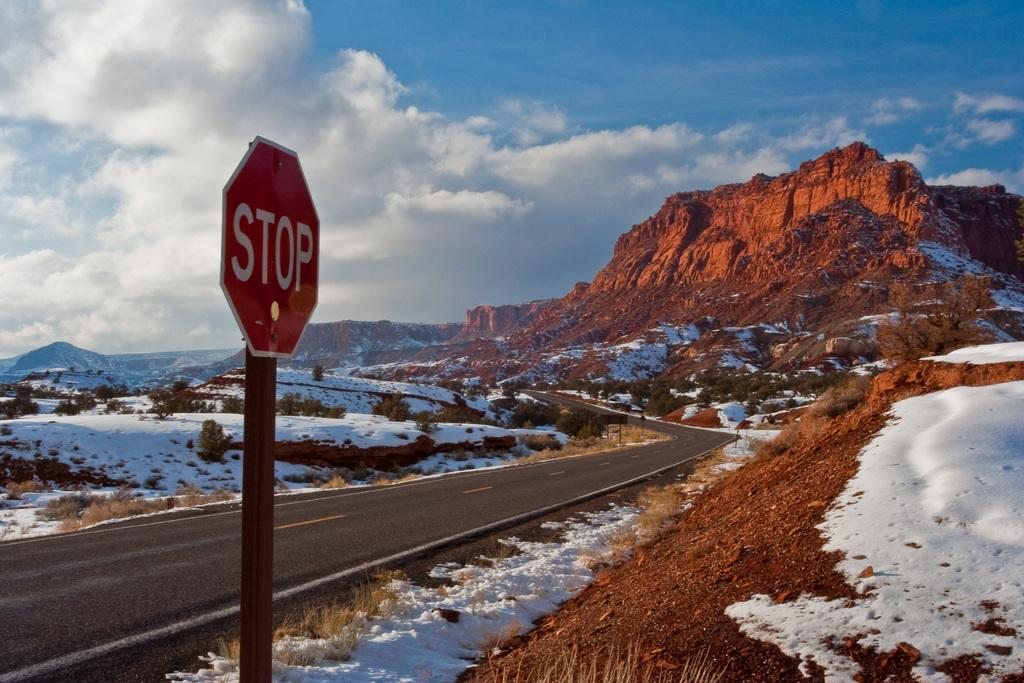<image>
Give a short and clear explanation of the subsequent image. Mountain in the background with a STOP sign in the front. 